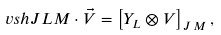<formula> <loc_0><loc_0><loc_500><loc_500>\ v s h { J } { L } { M } \cdot \vec { V } = \left [ Y _ { L } \otimes V \right ] _ { J \, M } ,</formula> 